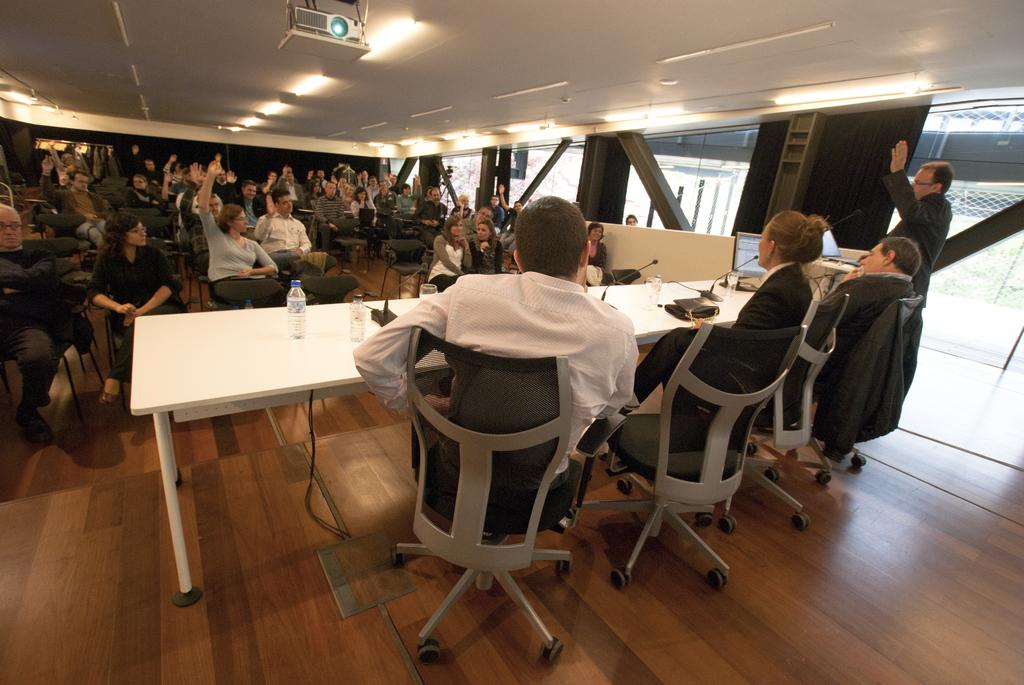What are the persons in the image doing? The persons in the image are sitting on chairs and raising their hands. What can be seen above the persons in the image? There are lights and a projector on top in the image. What objects are present on the table in the image? There are bottles, a monitor, and glasses on the table in the image. What type of chin can be seen on the monitor in the image? There is no chin present on the monitor in the image; it is a display screen for visual content. 